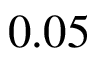Convert formula to latex. <formula><loc_0><loc_0><loc_500><loc_500>0 . 0 5</formula> 